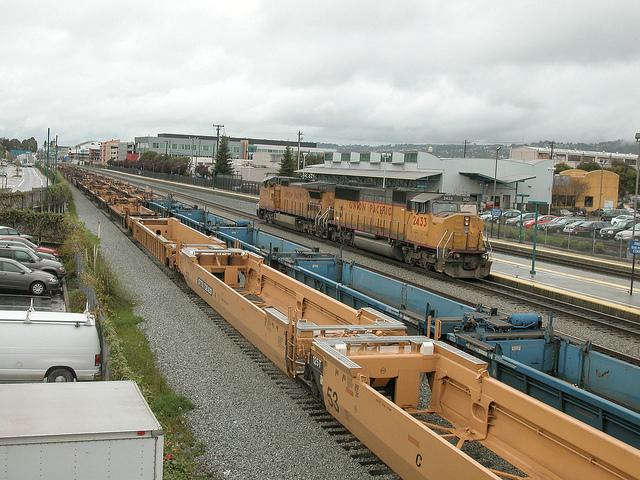IS the roof checked or spotted?
Short answer required. Checked. Where is this?
Concise answer only. Train depot. How many blue trains are there?
Write a very short answer. 5. 